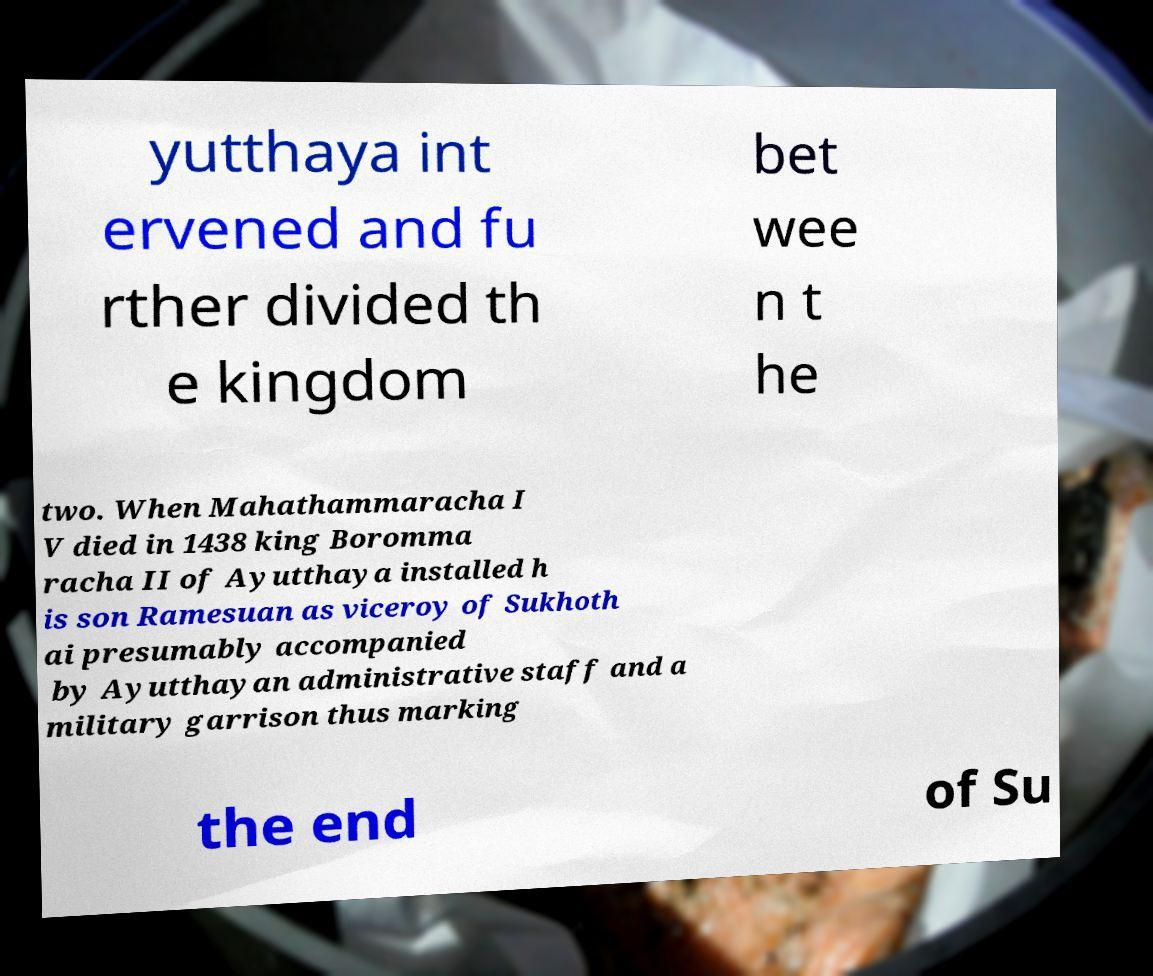For documentation purposes, I need the text within this image transcribed. Could you provide that? yutthaya int ervened and fu rther divided th e kingdom bet wee n t he two. When Mahathammaracha I V died in 1438 king Boromma racha II of Ayutthaya installed h is son Ramesuan as viceroy of Sukhoth ai presumably accompanied by Ayutthayan administrative staff and a military garrison thus marking the end of Su 